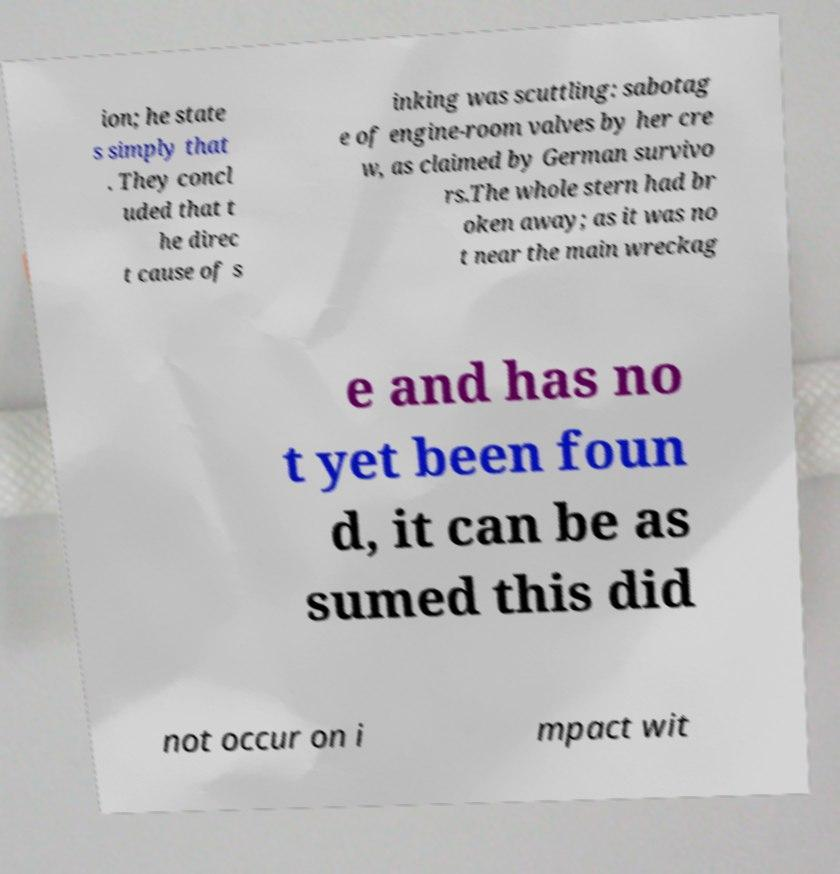Please read and relay the text visible in this image. What does it say? ion; he state s simply that . They concl uded that t he direc t cause of s inking was scuttling: sabotag e of engine-room valves by her cre w, as claimed by German survivo rs.The whole stern had br oken away; as it was no t near the main wreckag e and has no t yet been foun d, it can be as sumed this did not occur on i mpact wit 